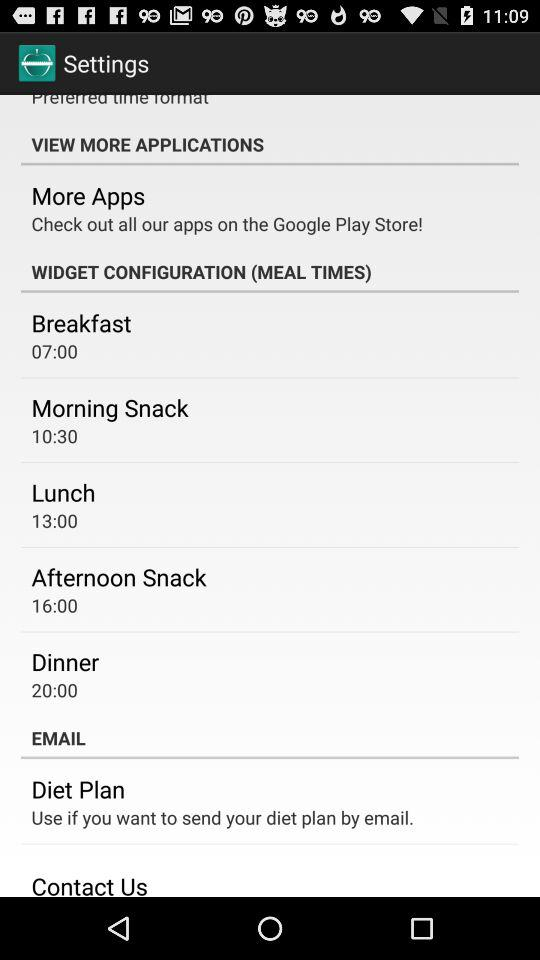What is lunch time? Lunch time is 13:00. 